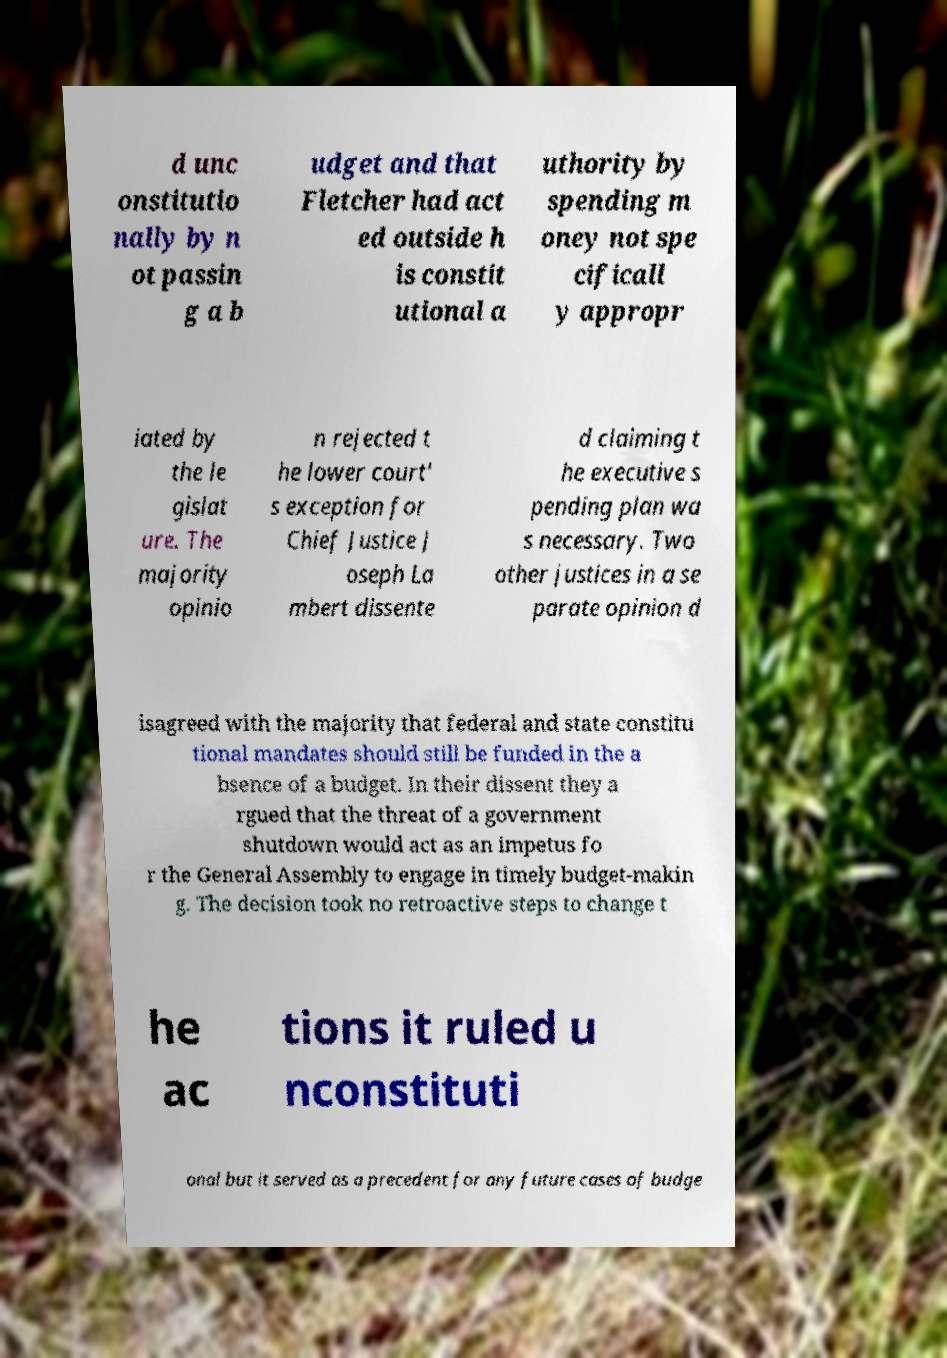There's text embedded in this image that I need extracted. Can you transcribe it verbatim? d unc onstitutio nally by n ot passin g a b udget and that Fletcher had act ed outside h is constit utional a uthority by spending m oney not spe cificall y appropr iated by the le gislat ure. The majority opinio n rejected t he lower court' s exception for Chief Justice J oseph La mbert dissente d claiming t he executive s pending plan wa s necessary. Two other justices in a se parate opinion d isagreed with the majority that federal and state constitu tional mandates should still be funded in the a bsence of a budget. In their dissent they a rgued that the threat of a government shutdown would act as an impetus fo r the General Assembly to engage in timely budget-makin g. The decision took no retroactive steps to change t he ac tions it ruled u nconstituti onal but it served as a precedent for any future cases of budge 